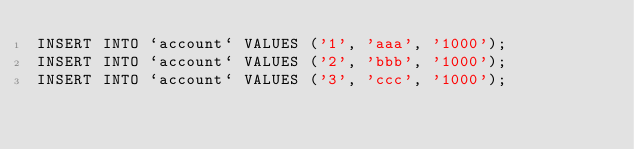<code> <loc_0><loc_0><loc_500><loc_500><_SQL_>INSERT INTO `account` VALUES ('1', 'aaa', '1000');
INSERT INTO `account` VALUES ('2', 'bbb', '1000');
INSERT INTO `account` VALUES ('3', 'ccc', '1000');</code> 